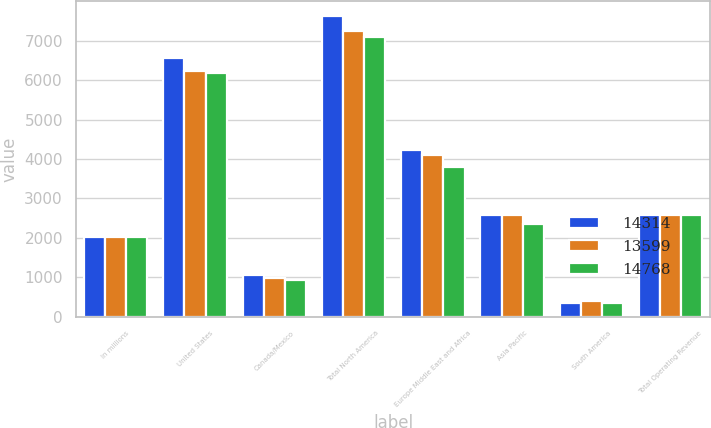Convert chart. <chart><loc_0><loc_0><loc_500><loc_500><stacked_bar_chart><ecel><fcel>In millions<fcel>United States<fcel>Canada/Mexico<fcel>Total North America<fcel>Europe Middle East and Africa<fcel>Asia Pacific<fcel>South America<fcel>Total Operating Revenue<nl><fcel>14314<fcel>2018<fcel>6562<fcel>1050<fcel>7612<fcel>4241<fcel>2573<fcel>342<fcel>2573<nl><fcel>13599<fcel>2017<fcel>6243<fcel>996<fcel>7239<fcel>4102<fcel>2577<fcel>396<fcel>2573<nl><fcel>14768<fcel>2016<fcel>6176<fcel>923<fcel>7099<fcel>3787<fcel>2361<fcel>352<fcel>2573<nl></chart> 